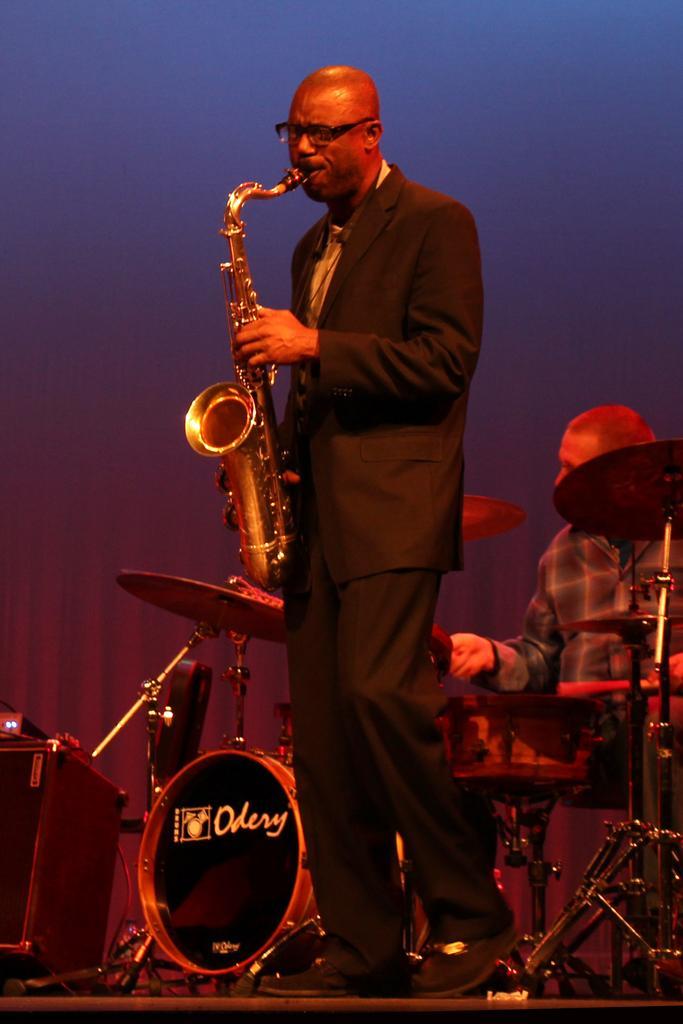How would you summarize this image in a sentence or two? In this image we can see a man standing on the stage. He is wearing a suit and a tie and he is playing the saxophone. In the background, we can see another man sitting on a chair and he is playing the snare drums. 